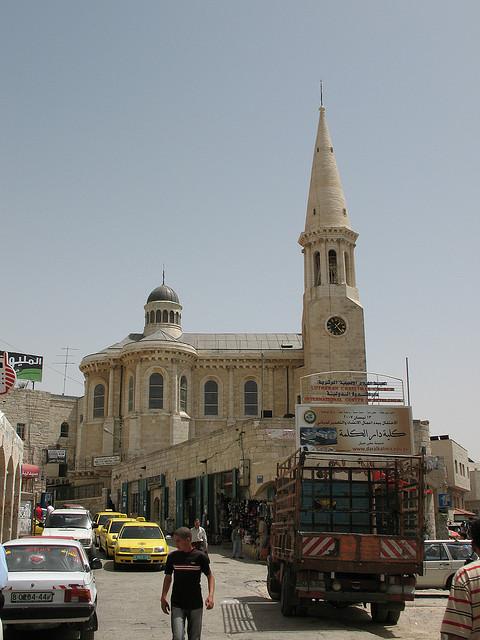How many yellow vehicles are in this photo?
Quick response, please. 3. Is this picture taken in the United States?
Quick response, please. No. What color is the dome on the building in the background?
Be succinct. Brown. What company name is on the bus?
Quick response, please. None. What is the building?
Quick response, please. Church. How many cars are in this photo?
Be succinct. 6. Is there a clock visible?
Be succinct. Yes. 